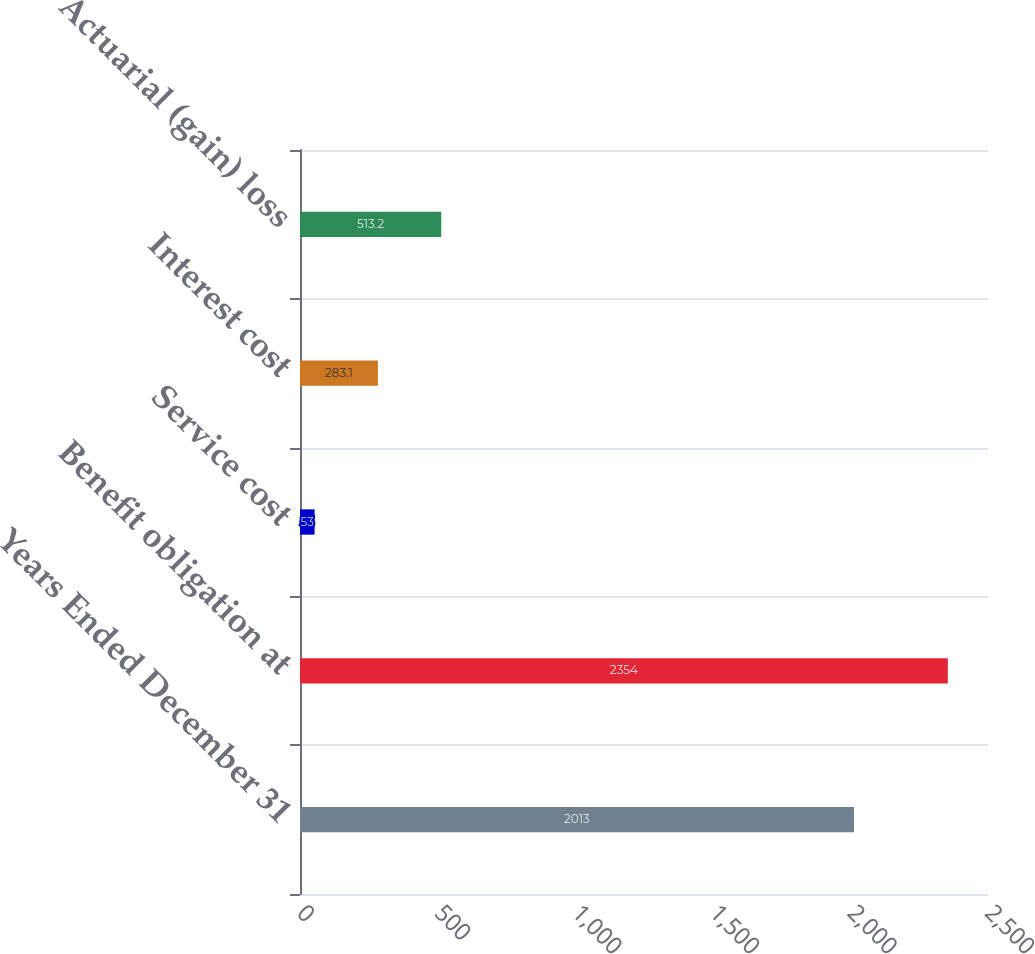Convert chart. <chart><loc_0><loc_0><loc_500><loc_500><bar_chart><fcel>Years Ended December 31<fcel>Benefit obligation at<fcel>Service cost<fcel>Interest cost<fcel>Actuarial (gain) loss<nl><fcel>2013<fcel>2354<fcel>53<fcel>283.1<fcel>513.2<nl></chart> 